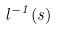<formula> <loc_0><loc_0><loc_500><loc_500>l ^ { - 1 } ( s )</formula> 